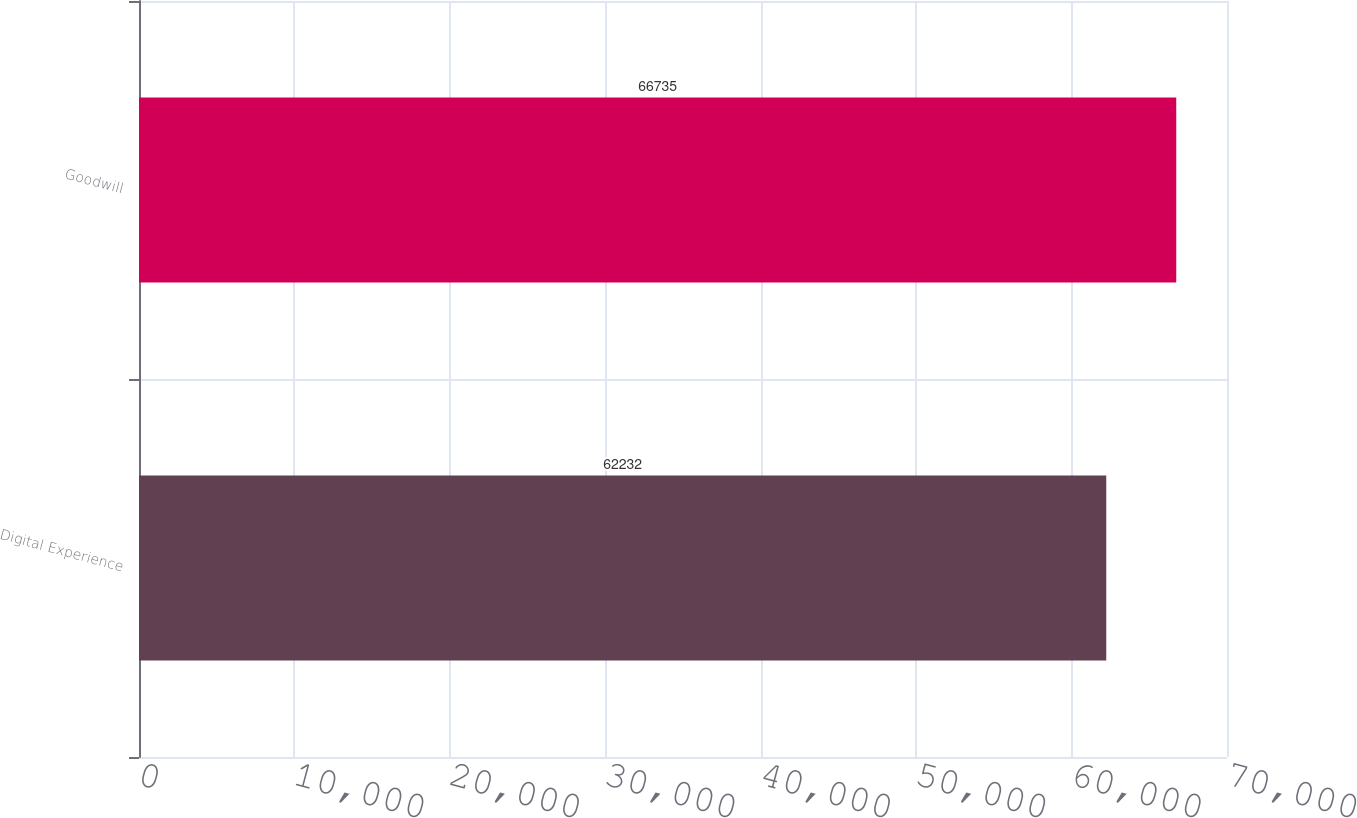Convert chart to OTSL. <chart><loc_0><loc_0><loc_500><loc_500><bar_chart><fcel>Digital Experience<fcel>Goodwill<nl><fcel>62232<fcel>66735<nl></chart> 